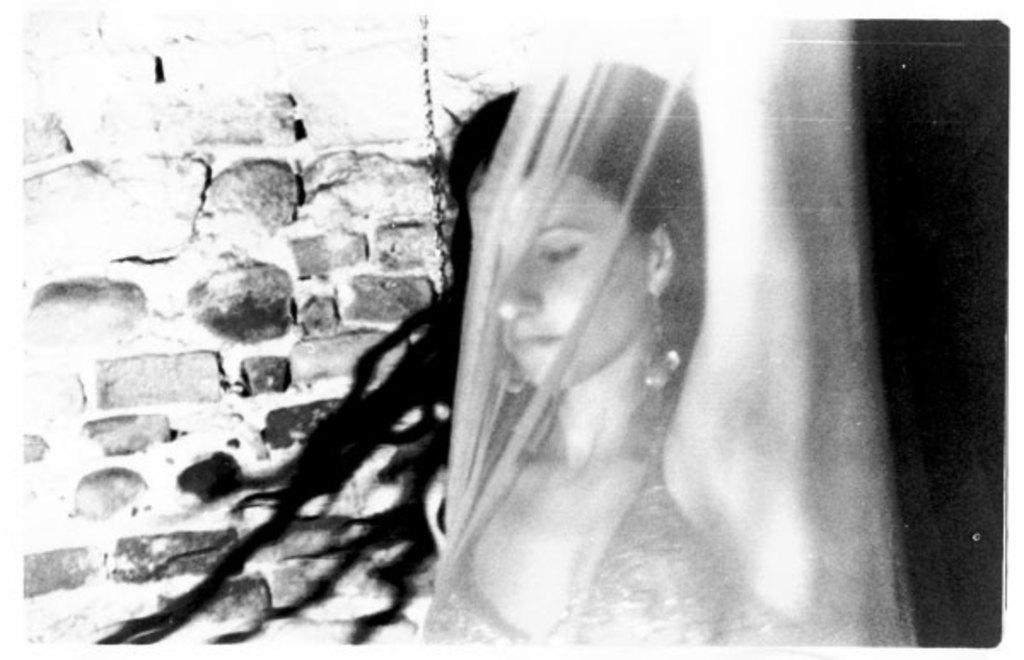What is the color scheme of the image? The image is black and white. Who is present in the image? There is a woman in the image. What is the woman's position in relation to the cover? The woman is behind a cover. What can be seen in the background of the image? There is a stone wall in the background of the image. How would you describe the overall lighting in the image? The background of the image is dark. What type of fruit is being used as a surprise prop in the image? There is no fruit or surprise prop present in the image. What type of prison can be seen in the background of the image? There is no prison visible in the image; it features a woman behind a cover with a stone wall in the background. 